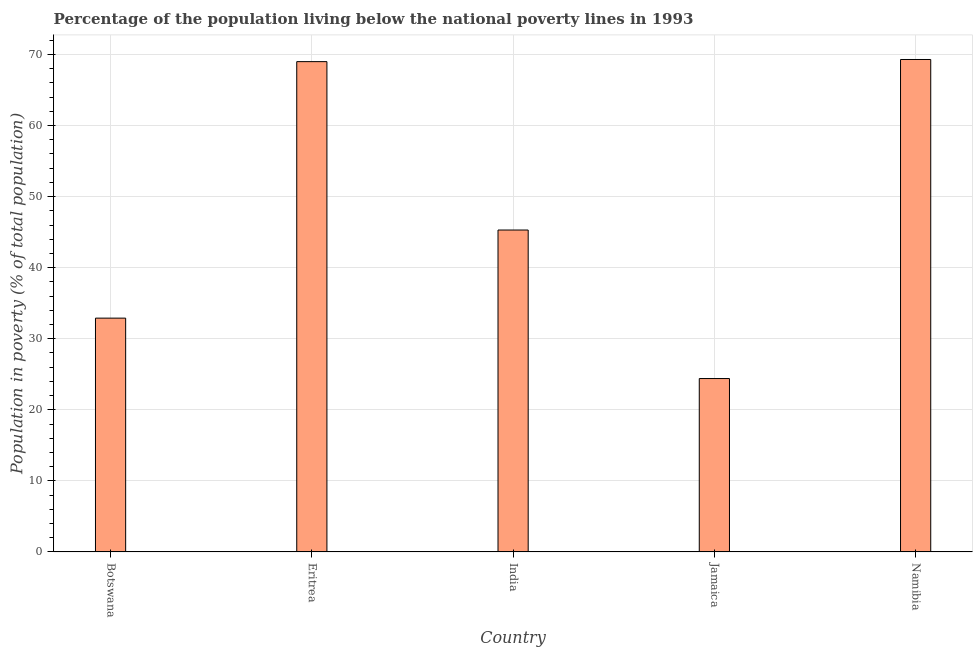Does the graph contain any zero values?
Your answer should be compact. No. Does the graph contain grids?
Make the answer very short. Yes. What is the title of the graph?
Your answer should be very brief. Percentage of the population living below the national poverty lines in 1993. What is the label or title of the X-axis?
Offer a very short reply. Country. What is the label or title of the Y-axis?
Offer a terse response. Population in poverty (% of total population). What is the percentage of population living below poverty line in India?
Ensure brevity in your answer.  45.3. Across all countries, what is the maximum percentage of population living below poverty line?
Give a very brief answer. 69.3. Across all countries, what is the minimum percentage of population living below poverty line?
Your answer should be compact. 24.4. In which country was the percentage of population living below poverty line maximum?
Keep it short and to the point. Namibia. In which country was the percentage of population living below poverty line minimum?
Ensure brevity in your answer.  Jamaica. What is the sum of the percentage of population living below poverty line?
Offer a very short reply. 240.9. What is the difference between the percentage of population living below poverty line in Botswana and Eritrea?
Keep it short and to the point. -36.1. What is the average percentage of population living below poverty line per country?
Provide a short and direct response. 48.18. What is the median percentage of population living below poverty line?
Your response must be concise. 45.3. In how many countries, is the percentage of population living below poverty line greater than 28 %?
Give a very brief answer. 4. What is the ratio of the percentage of population living below poverty line in India to that in Jamaica?
Make the answer very short. 1.86. Is the percentage of population living below poverty line in Botswana less than that in Namibia?
Offer a terse response. Yes. What is the difference between the highest and the second highest percentage of population living below poverty line?
Your response must be concise. 0.3. Is the sum of the percentage of population living below poverty line in Jamaica and Namibia greater than the maximum percentage of population living below poverty line across all countries?
Your response must be concise. Yes. What is the difference between the highest and the lowest percentage of population living below poverty line?
Provide a short and direct response. 44.9. Are the values on the major ticks of Y-axis written in scientific E-notation?
Your response must be concise. No. What is the Population in poverty (% of total population) in Botswana?
Provide a short and direct response. 32.9. What is the Population in poverty (% of total population) in Eritrea?
Offer a very short reply. 69. What is the Population in poverty (% of total population) in India?
Provide a short and direct response. 45.3. What is the Population in poverty (% of total population) in Jamaica?
Make the answer very short. 24.4. What is the Population in poverty (% of total population) of Namibia?
Give a very brief answer. 69.3. What is the difference between the Population in poverty (% of total population) in Botswana and Eritrea?
Give a very brief answer. -36.1. What is the difference between the Population in poverty (% of total population) in Botswana and Namibia?
Your answer should be compact. -36.4. What is the difference between the Population in poverty (% of total population) in Eritrea and India?
Keep it short and to the point. 23.7. What is the difference between the Population in poverty (% of total population) in Eritrea and Jamaica?
Offer a terse response. 44.6. What is the difference between the Population in poverty (% of total population) in India and Jamaica?
Provide a short and direct response. 20.9. What is the difference between the Population in poverty (% of total population) in Jamaica and Namibia?
Ensure brevity in your answer.  -44.9. What is the ratio of the Population in poverty (% of total population) in Botswana to that in Eritrea?
Keep it short and to the point. 0.48. What is the ratio of the Population in poverty (% of total population) in Botswana to that in India?
Ensure brevity in your answer.  0.73. What is the ratio of the Population in poverty (% of total population) in Botswana to that in Jamaica?
Your answer should be very brief. 1.35. What is the ratio of the Population in poverty (% of total population) in Botswana to that in Namibia?
Your answer should be compact. 0.47. What is the ratio of the Population in poverty (% of total population) in Eritrea to that in India?
Offer a terse response. 1.52. What is the ratio of the Population in poverty (% of total population) in Eritrea to that in Jamaica?
Provide a succinct answer. 2.83. What is the ratio of the Population in poverty (% of total population) in India to that in Jamaica?
Ensure brevity in your answer.  1.86. What is the ratio of the Population in poverty (% of total population) in India to that in Namibia?
Make the answer very short. 0.65. What is the ratio of the Population in poverty (% of total population) in Jamaica to that in Namibia?
Provide a short and direct response. 0.35. 